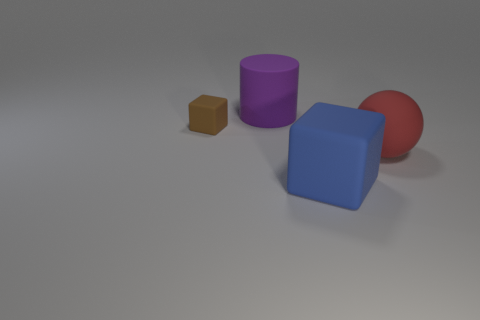There is a blue thing that is the same shape as the brown object; what is it made of?
Your response must be concise. Rubber. There is a tiny brown matte object; is it the same shape as the big object that is behind the tiny rubber cube?
Your answer should be compact. No. What number of big blue shiny things are the same shape as the tiny brown rubber thing?
Make the answer very short. 0. There is a large red matte thing; what shape is it?
Keep it short and to the point. Sphere. What is the size of the block that is in front of the brown block behind the big blue matte cube?
Provide a succinct answer. Large. What number of objects are either brown cubes or small green objects?
Your answer should be very brief. 1. Is the blue matte object the same shape as the purple rubber thing?
Your answer should be compact. No. Are there any red spheres made of the same material as the big purple object?
Give a very brief answer. Yes. Is there a matte object that is behind the rubber block that is behind the big red thing?
Offer a very short reply. Yes. Is the size of the cube that is right of the rubber cylinder the same as the purple matte cylinder?
Offer a very short reply. Yes. 